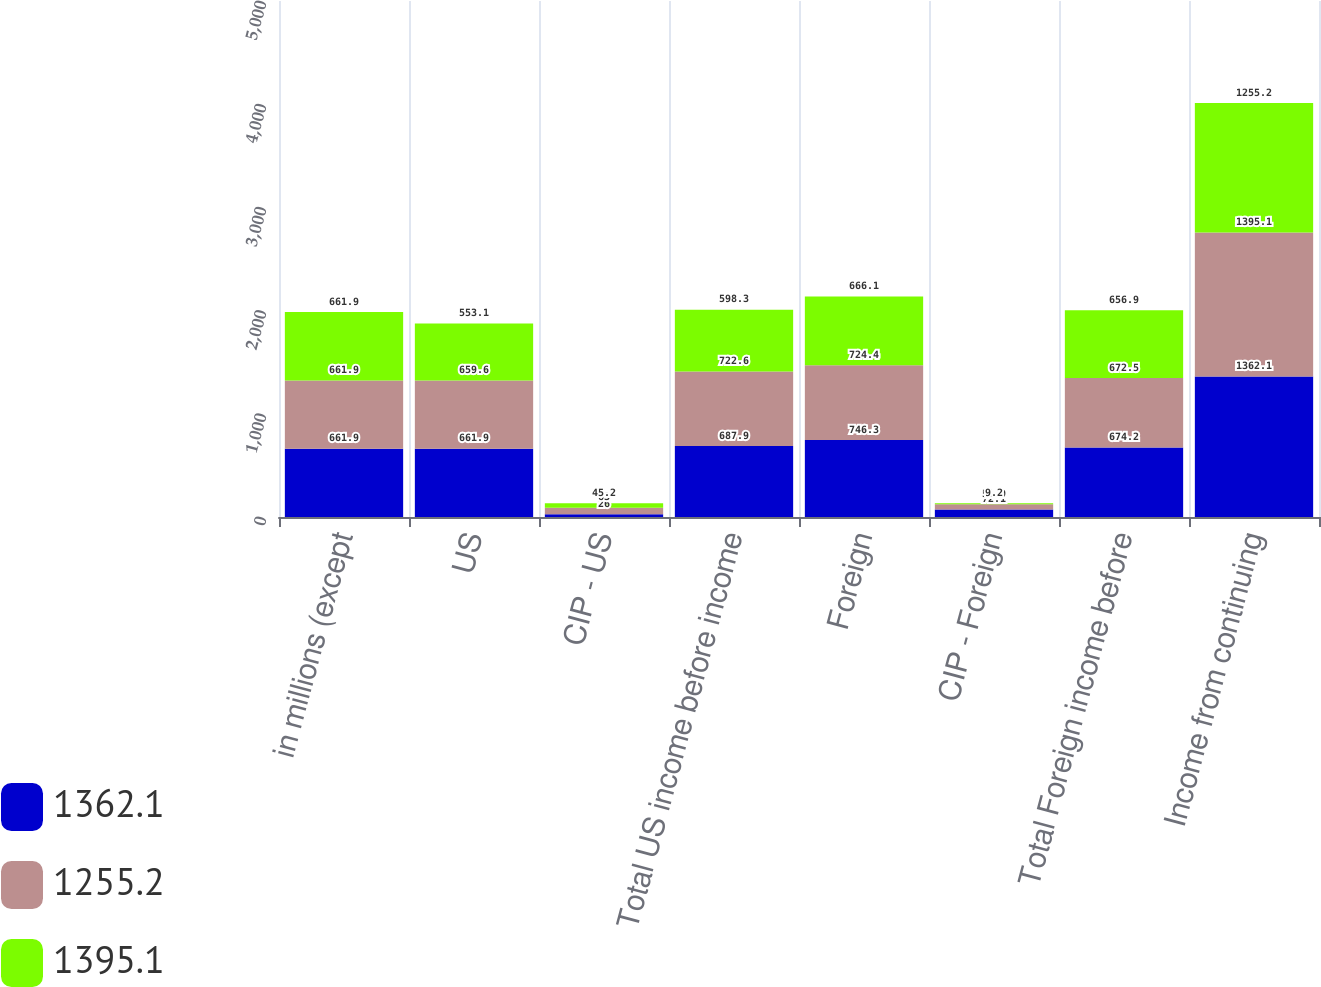Convert chart. <chart><loc_0><loc_0><loc_500><loc_500><stacked_bar_chart><ecel><fcel>in millions (except<fcel>US<fcel>CIP - US<fcel>Total US income before income<fcel>Foreign<fcel>CIP - Foreign<fcel>Total Foreign income before<fcel>Income from continuing<nl><fcel>1362.1<fcel>661.9<fcel>661.9<fcel>26<fcel>687.9<fcel>746.3<fcel>72.1<fcel>674.2<fcel>1362.1<nl><fcel>1255.2<fcel>661.9<fcel>659.6<fcel>63<fcel>722.6<fcel>724.4<fcel>51.9<fcel>672.5<fcel>1395.1<nl><fcel>1395.1<fcel>661.9<fcel>553.1<fcel>45.2<fcel>598.3<fcel>666.1<fcel>9.2<fcel>656.9<fcel>1255.2<nl></chart> 